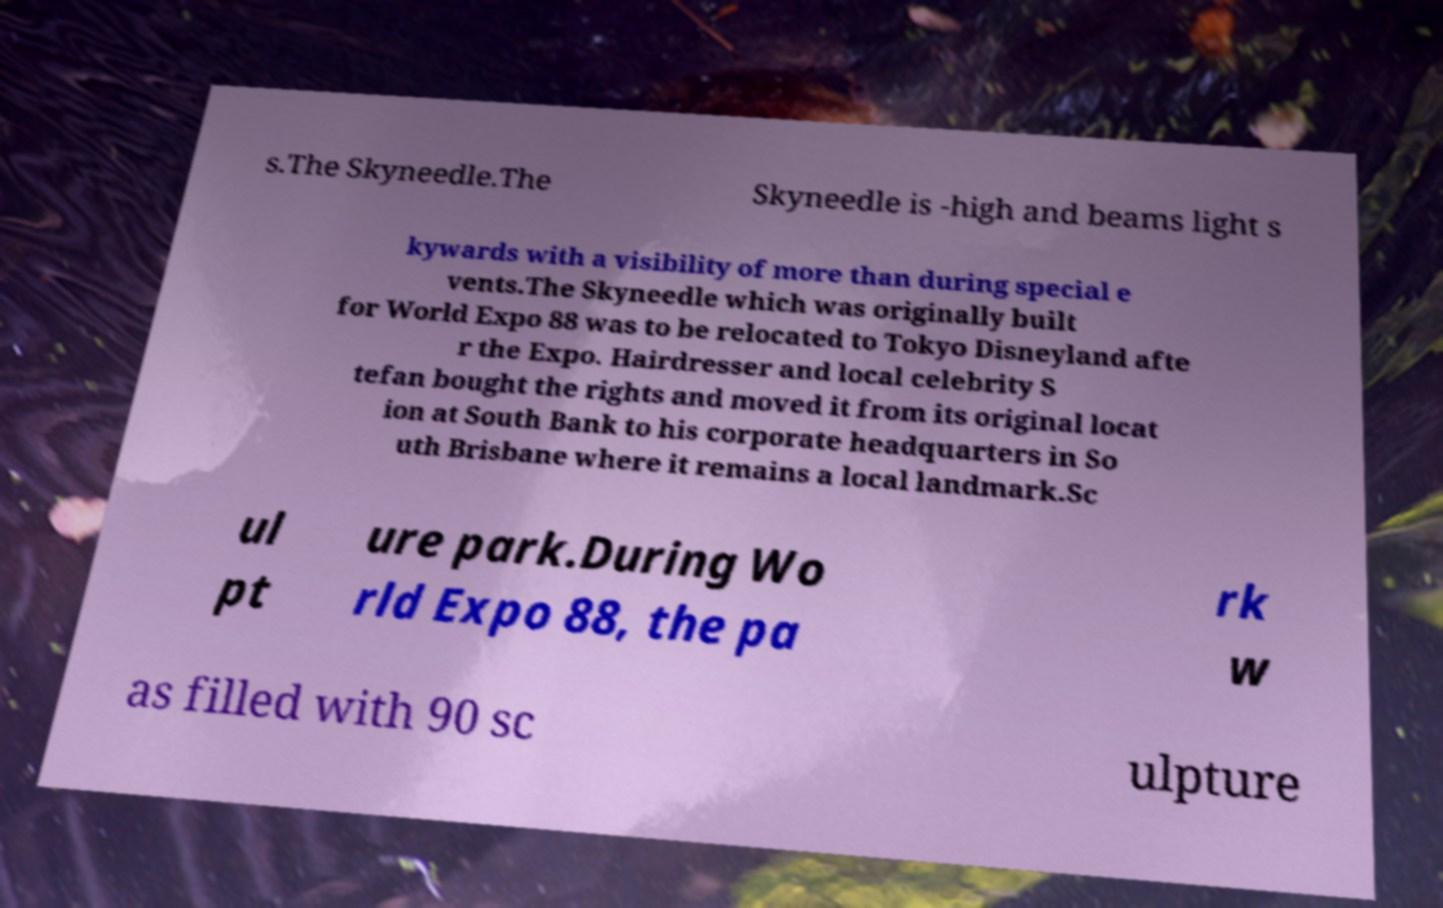There's text embedded in this image that I need extracted. Can you transcribe it verbatim? s.The Skyneedle.The Skyneedle is -high and beams light s kywards with a visibility of more than during special e vents.The Skyneedle which was originally built for World Expo 88 was to be relocated to Tokyo Disneyland afte r the Expo. Hairdresser and local celebrity S tefan bought the rights and moved it from its original locat ion at South Bank to his corporate headquarters in So uth Brisbane where it remains a local landmark.Sc ul pt ure park.During Wo rld Expo 88, the pa rk w as filled with 90 sc ulpture 